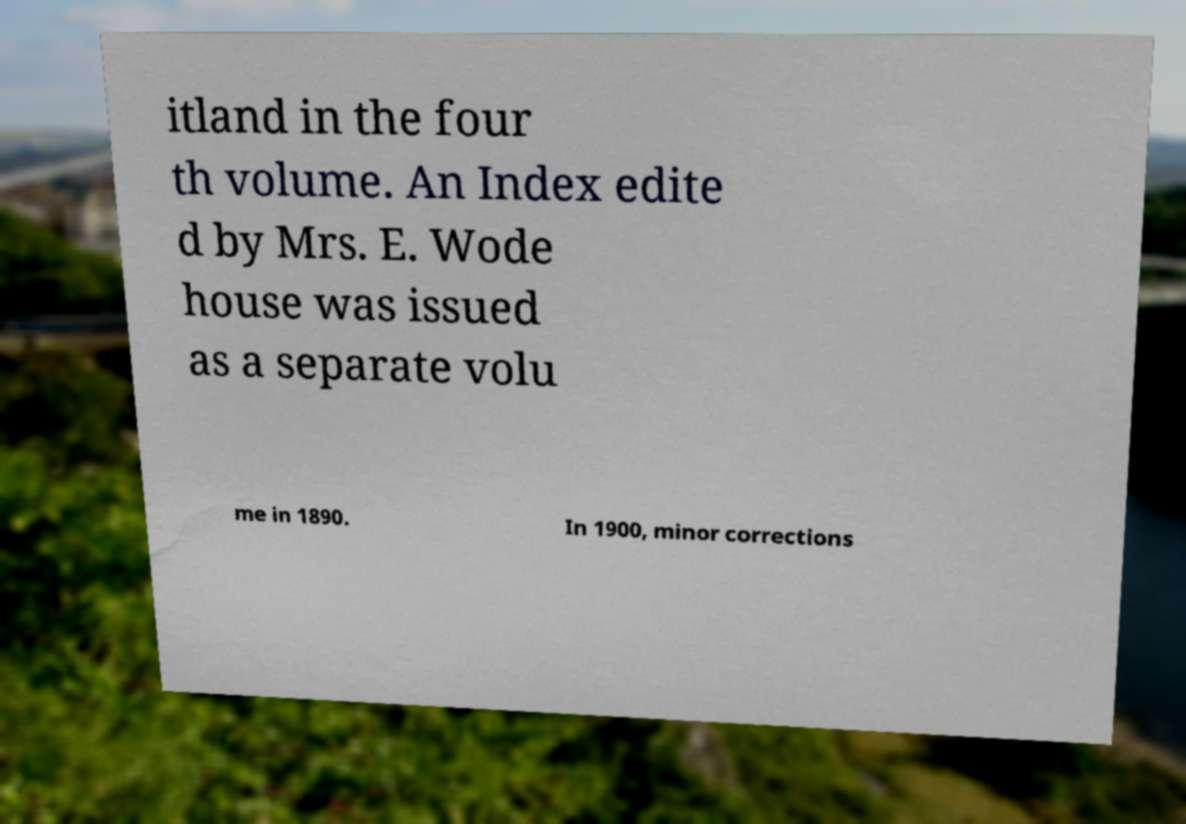I need the written content from this picture converted into text. Can you do that? itland in the four th volume. An Index edite d by Mrs. E. Wode house was issued as a separate volu me in 1890. In 1900, minor corrections 